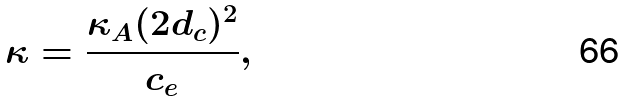Convert formula to latex. <formula><loc_0><loc_0><loc_500><loc_500>\kappa = \frac { \kappa _ { A } ( 2 d _ { c } ) ^ { 2 } } { c _ { e } } ,</formula> 